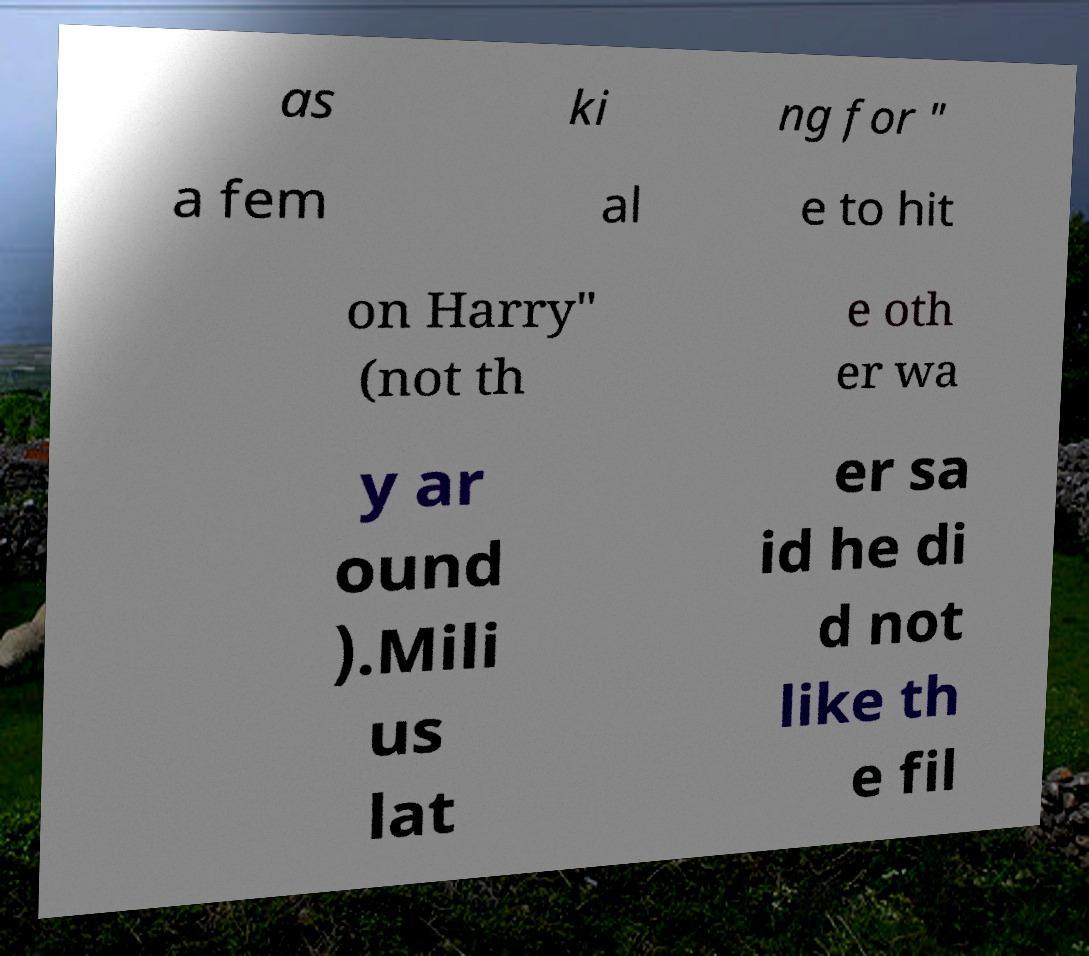Could you extract and type out the text from this image? as ki ng for " a fem al e to hit on Harry" (not th e oth er wa y ar ound ).Mili us lat er sa id he di d not like th e fil 